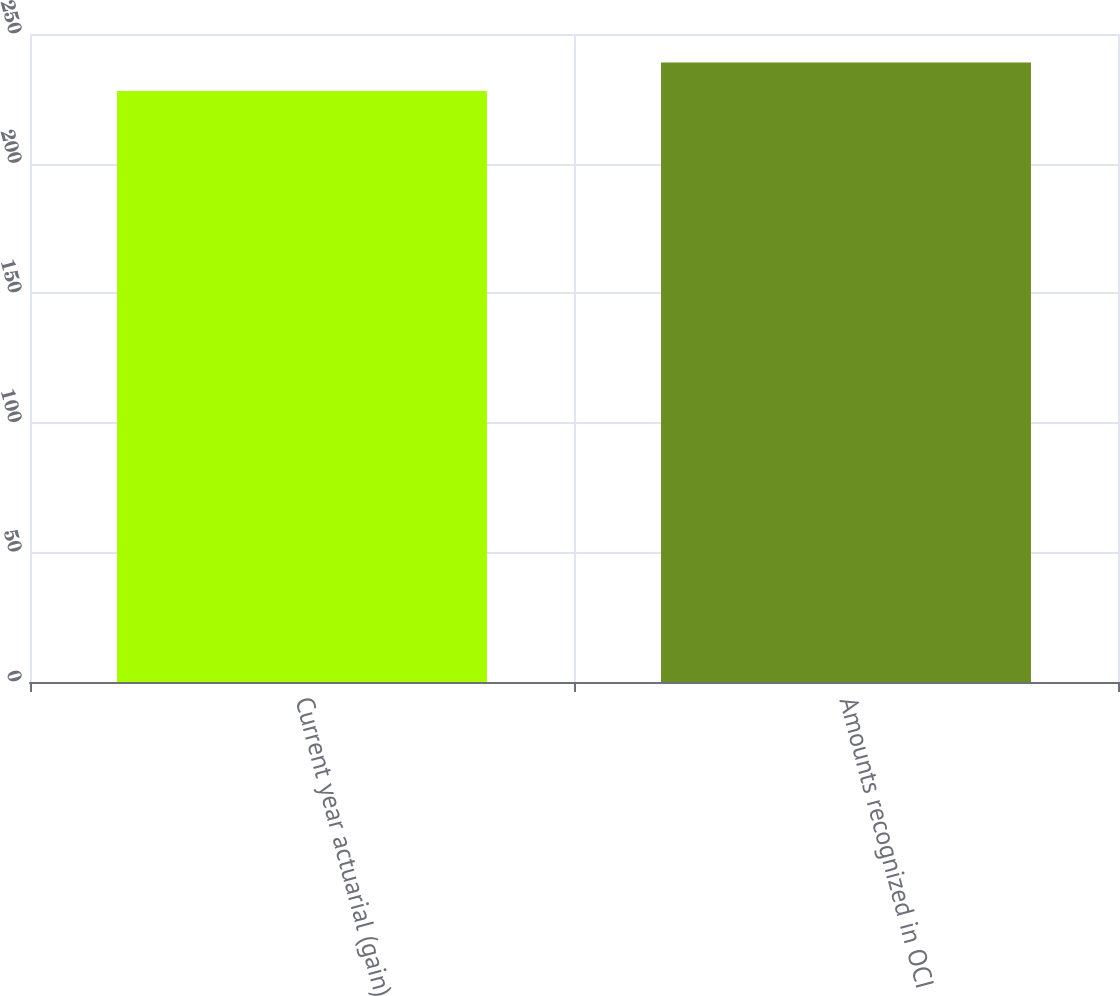<chart> <loc_0><loc_0><loc_500><loc_500><bar_chart><fcel>Current year actuarial (gain)<fcel>Amounts recognized in OCI<nl><fcel>228<fcel>239<nl></chart> 